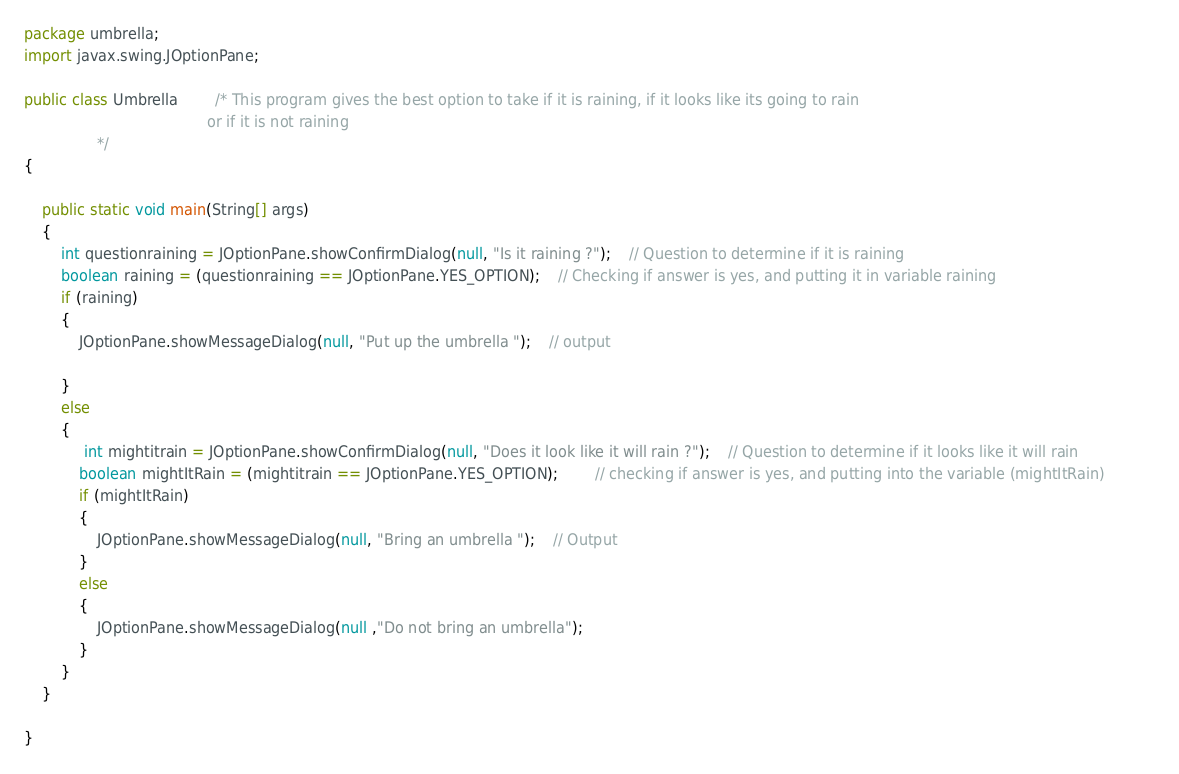<code> <loc_0><loc_0><loc_500><loc_500><_Java_>package umbrella;
import javax.swing.JOptionPane;

public class Umbrella 		/* This program gives the best option to take if it is raining, if it looks like its going to rain 
										or if it is not raining
				*/
{

	public static void main(String[] args) 
	{
		int questionraining = JOptionPane.showConfirmDialog(null, "Is it raining ?"); 	// Question to determine if it is raining
		boolean raining = (questionraining == JOptionPane.YES_OPTION);	// Checking if answer is yes, and putting it in variable raining
		if (raining)											
		{
			JOptionPane.showMessageDialog(null, "Put up the umbrella ");	// output
			
		}							
		else															
		{
			 int mightitrain = JOptionPane.showConfirmDialog(null, "Does it look like it will rain ?"); 	// Question to determine if it looks like it will rain
			boolean mightItRain = (mightitrain == JOptionPane.YES_OPTION); 		// checking if answer is yes, and putting into the variable (mightItRain)			
			if (mightItRain)							
			{
				JOptionPane.showMessageDialog(null, "Bring an umbrella ");	// Output
			}
			else																
			{
				JOptionPane.showMessageDialog(null ,"Do not bring an umbrella");		
			}
		}
	}

}
</code> 